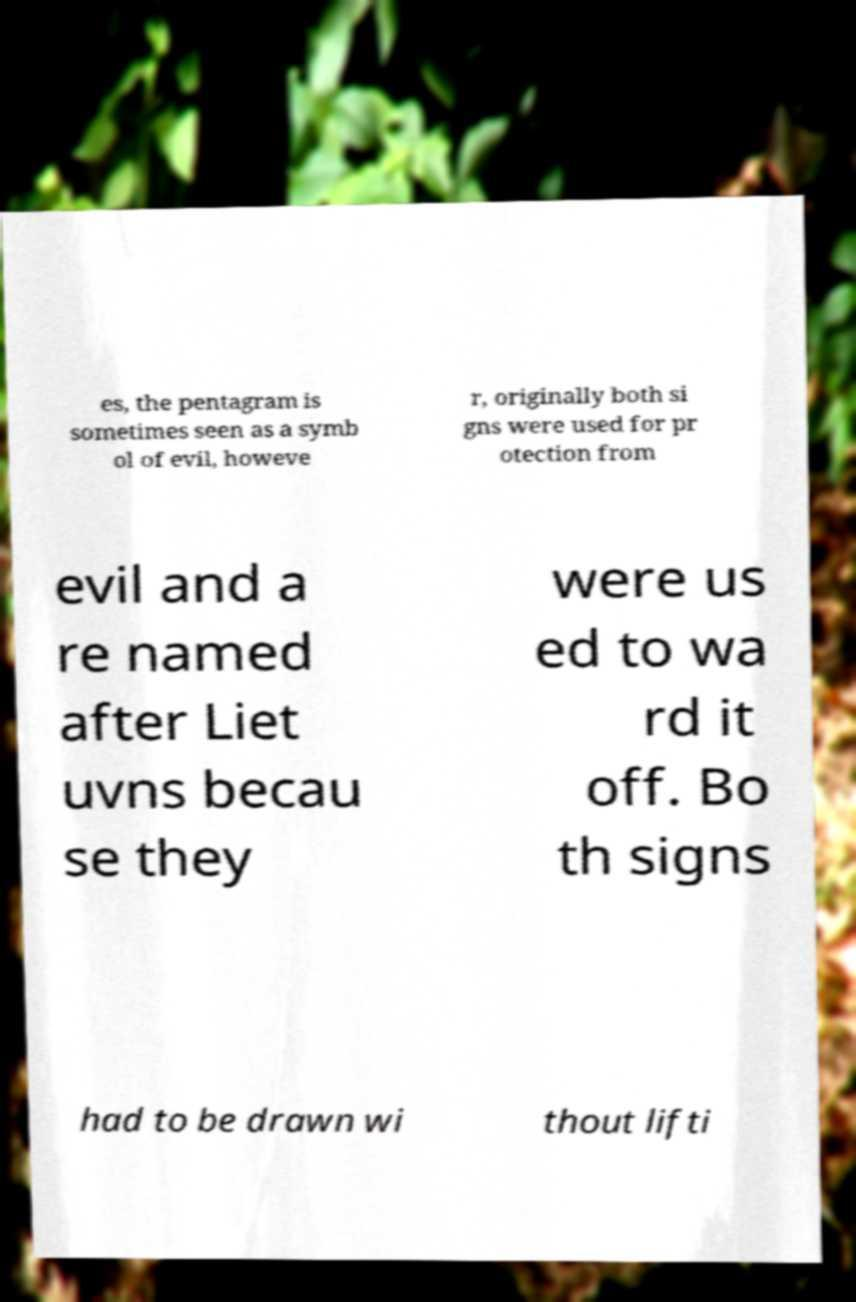Please read and relay the text visible in this image. What does it say? es, the pentagram is sometimes seen as a symb ol of evil, howeve r, originally both si gns were used for pr otection from evil and a re named after Liet uvns becau se they were us ed to wa rd it off. Bo th signs had to be drawn wi thout lifti 